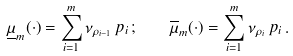<formula> <loc_0><loc_0><loc_500><loc_500>\underline { \mu } _ { m } ( \cdot ) = \sum _ { i = 1 } ^ { m } \nu _ { \rho _ { i - 1 } } \, p _ { i } \, ; \quad \overline { \mu } _ { m } ( \cdot ) = \sum _ { i = 1 } ^ { m } \nu _ { \rho _ { i } } \, p _ { i } \, .</formula> 